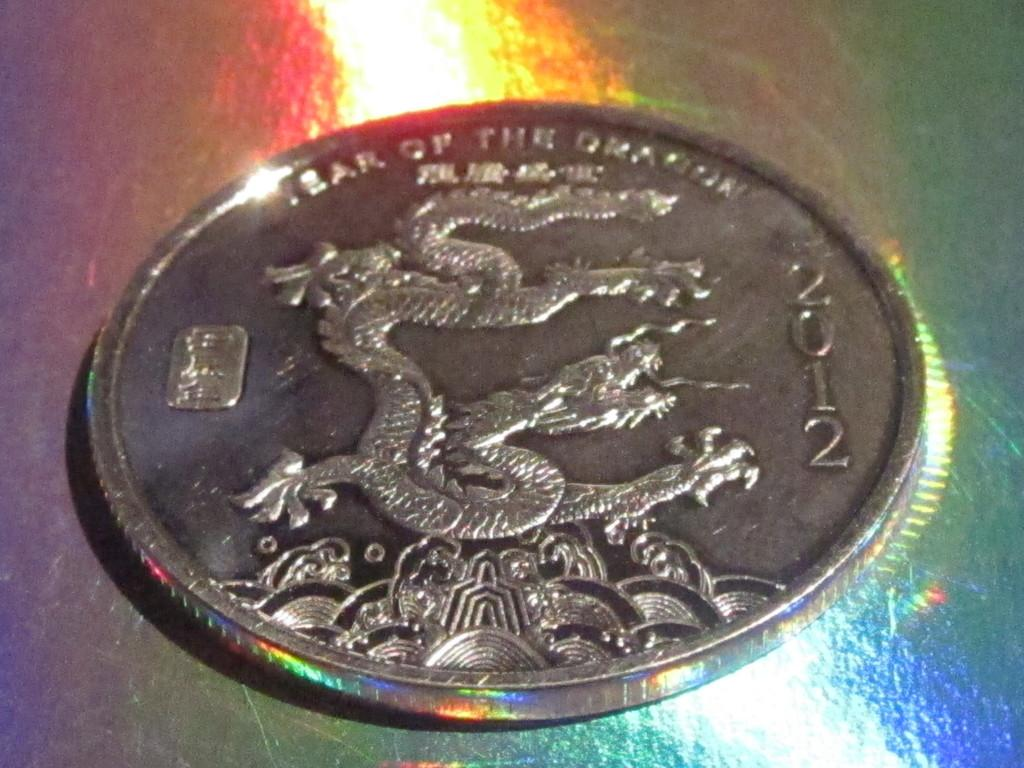<image>
Offer a succinct explanation of the picture presented. A silver coin with a dragon on it and the year 2012. 